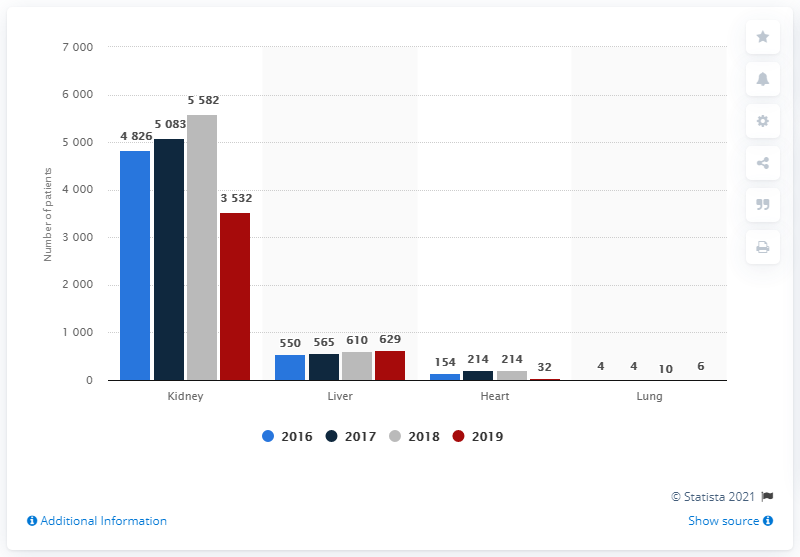Indicate a few pertinent items in this graphic. In 2019, there were 3,532 patients on the waiting list for a kidney transplant in Romania. 